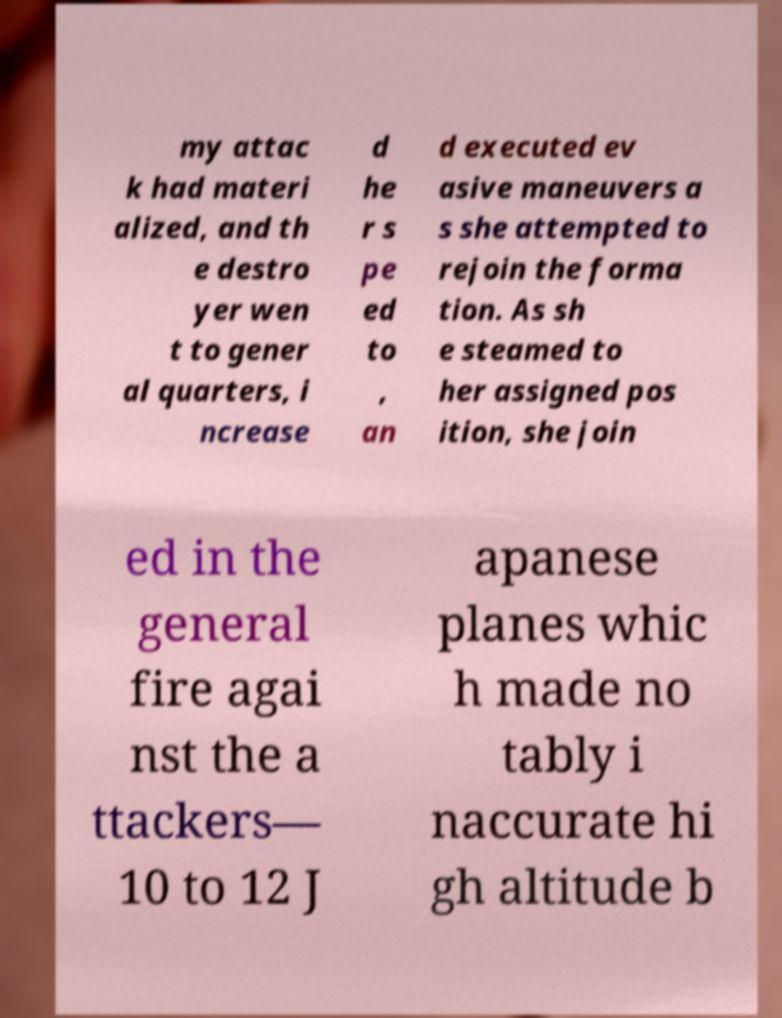There's text embedded in this image that I need extracted. Can you transcribe it verbatim? my attac k had materi alized, and th e destro yer wen t to gener al quarters, i ncrease d he r s pe ed to , an d executed ev asive maneuvers a s she attempted to rejoin the forma tion. As sh e steamed to her assigned pos ition, she join ed in the general fire agai nst the a ttackers— 10 to 12 J apanese planes whic h made no tably i naccurate hi gh altitude b 